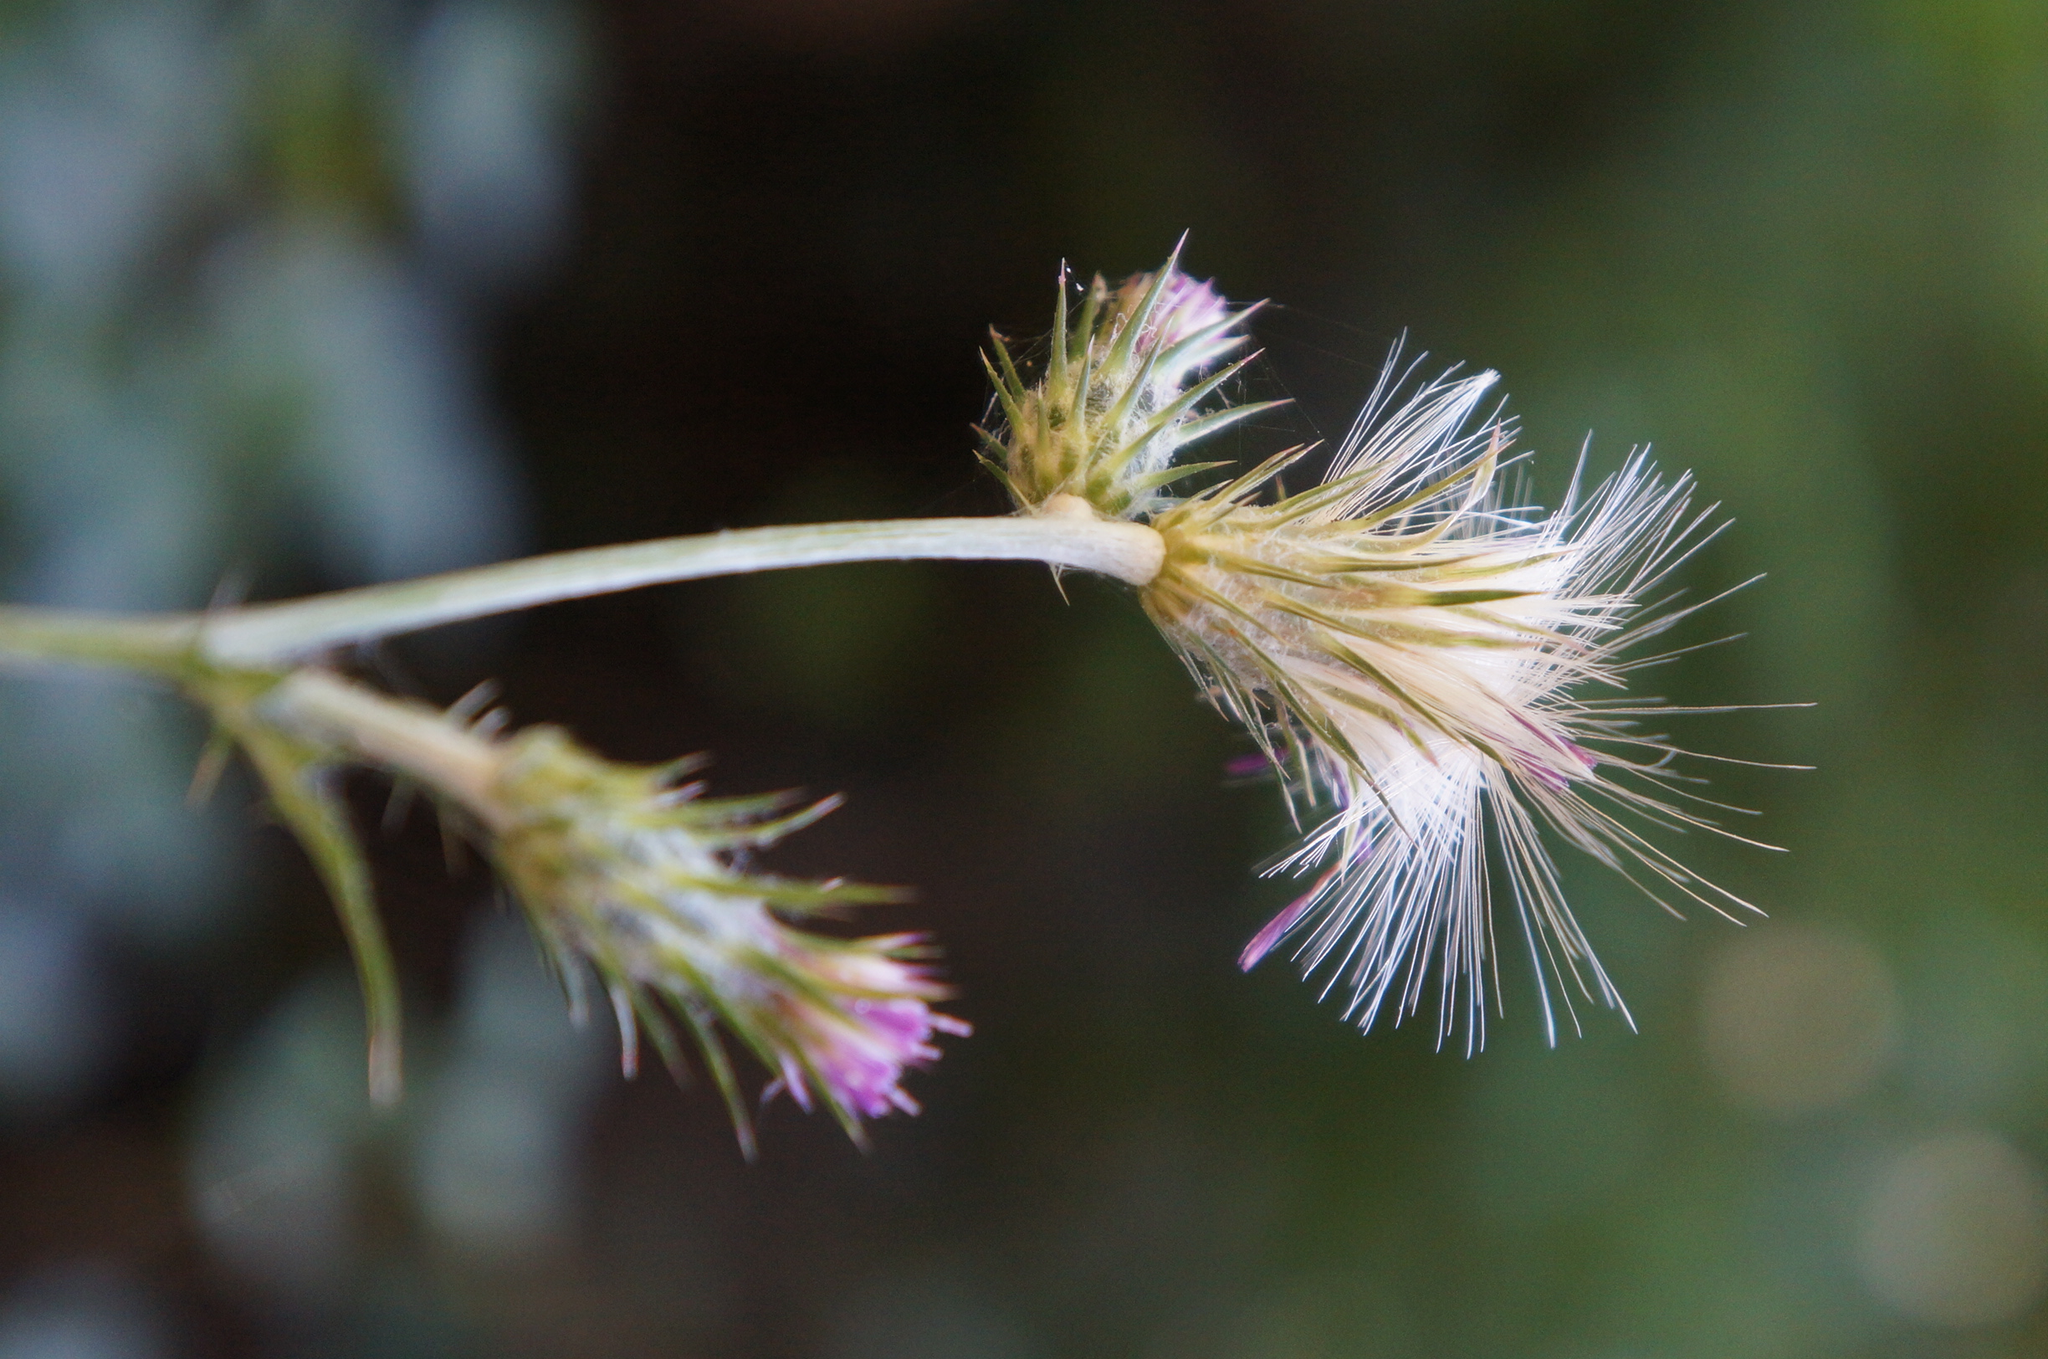Describe this image in one or two sentences. In the image we can see there is a flower. 